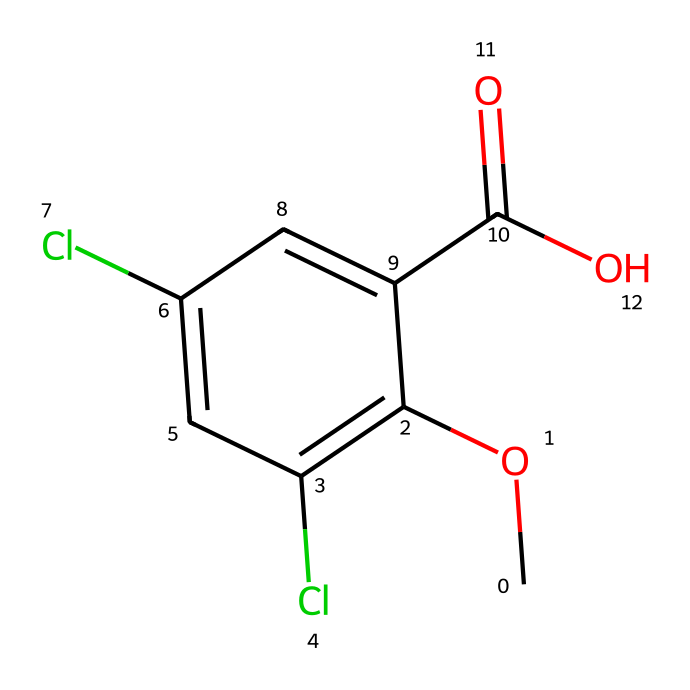What is the name of this herbicide? The SMILES representation indicates the chemical structure of dicamba, which is a well-known herbicide used for controlling broadleaf weeds in crops like soybeans.
Answer: dicamba How many chlorine atoms are present in this molecule? By analyzing the SMILES, we see that there are two 'Cl' notations, indicating the presence of two chlorine atoms in the structure.
Answer: 2 What functional group is present in dicamba? The structure includes a carboxylic acid functional group represented by 'C(=O)O' in the SMILES, indicating the presence of the -COOH group which is characteristic of carboxylic acids.
Answer: carboxylic acid What is the total number of carbon atoms in dicamba? Counting all the 'C' symbols in the SMILES, we find a total of 9 carbon atoms in the molecule.
Answer: 9 Is dicamba considered a selective herbicide? Dicamba is known for its selective action against broadleaf weeds, meaning it can control specific types of weeds without harming cereal crops like soybeans.
Answer: yes What type of chemical bond connects the carbon and oxygen in the carboxylic acid group? In the carboxylic acid functional group, the carbon and oxygen atoms are connected by a double bond (C=O) and a single bond (C-O), characterizing the typical bonding in this functional group.
Answer: covalent bonds What is the primary use of dicamba in agriculture? Dicamba is primarily used to control broadleaf weeds, particularly in soybean fields, helping to manage unwanted vegetation without damaging the soybean plants.
Answer: weed control 